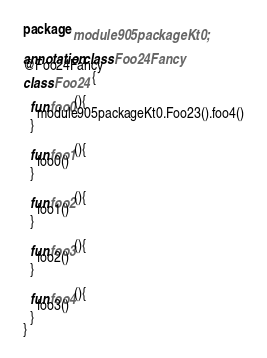<code> <loc_0><loc_0><loc_500><loc_500><_Kotlin_>package module905packageKt0;

annotation class Foo24Fancy
@Foo24Fancy
class Foo24 {

  fun foo0(){
    module905packageKt0.Foo23().foo4()
  }

  fun foo1(){
    foo0()
  }

  fun foo2(){
    foo1()
  }

  fun foo3(){
    foo2()
  }

  fun foo4(){
    foo3()
  }
}</code> 